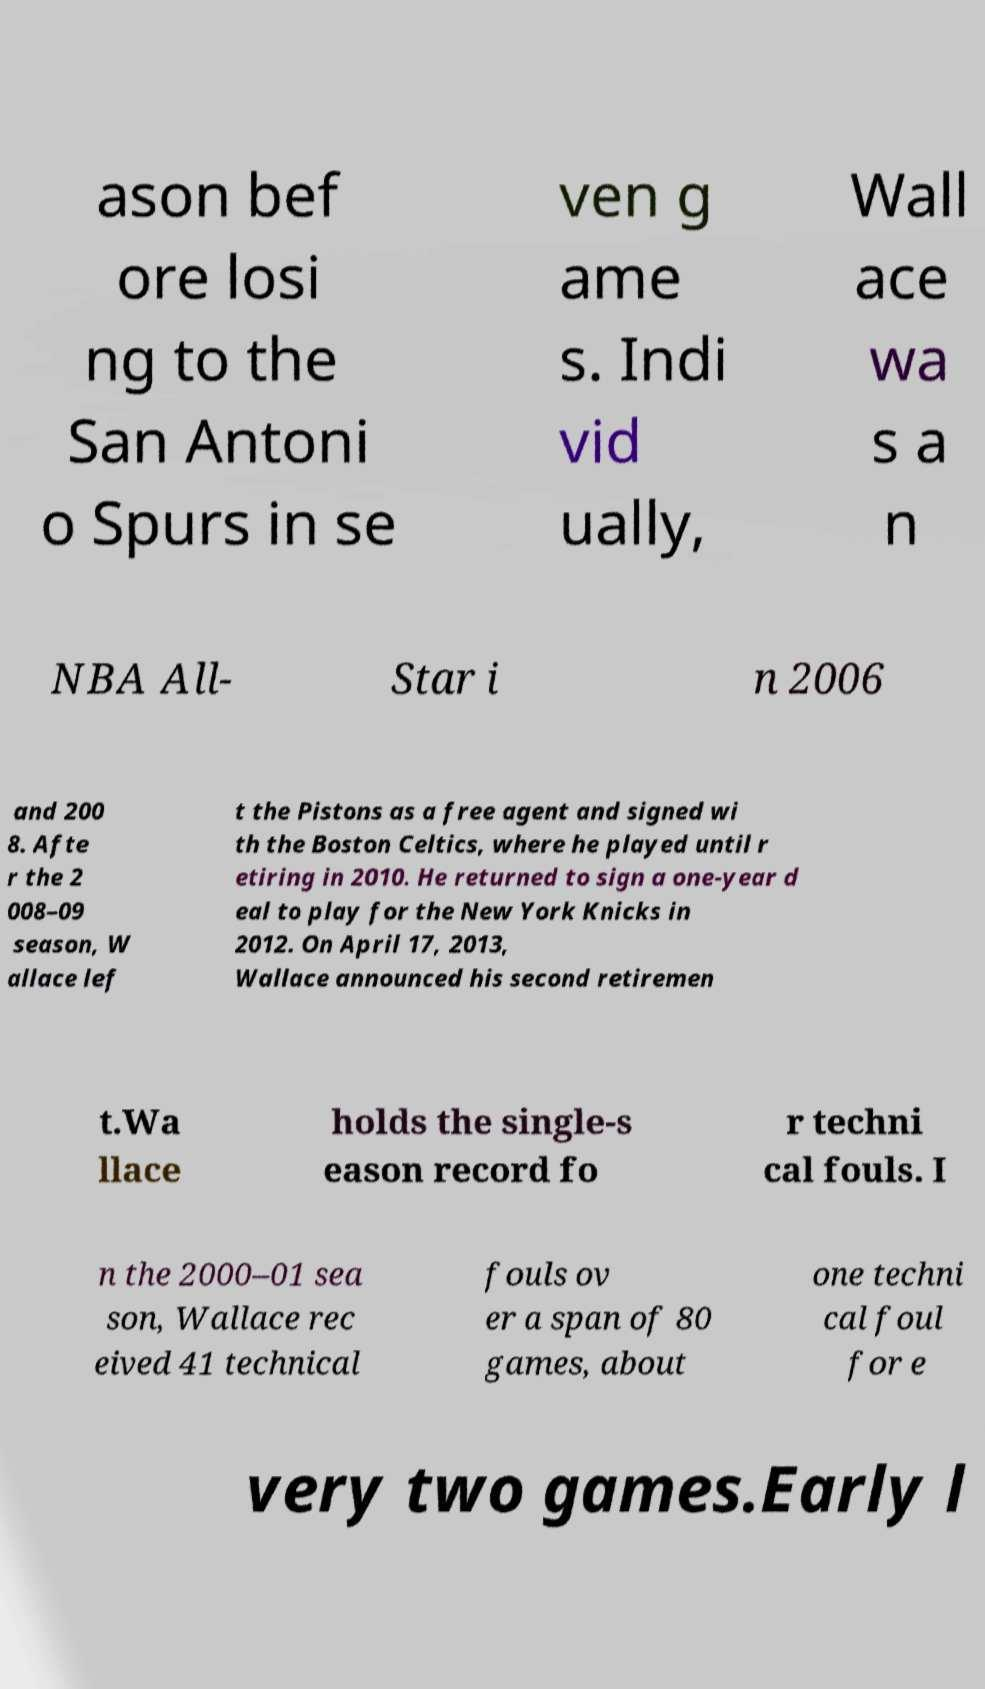Can you read and provide the text displayed in the image?This photo seems to have some interesting text. Can you extract and type it out for me? ason bef ore losi ng to the San Antoni o Spurs in se ven g ame s. Indi vid ually, Wall ace wa s a n NBA All- Star i n 2006 and 200 8. Afte r the 2 008–09 season, W allace lef t the Pistons as a free agent and signed wi th the Boston Celtics, where he played until r etiring in 2010. He returned to sign a one-year d eal to play for the New York Knicks in 2012. On April 17, 2013, Wallace announced his second retiremen t.Wa llace holds the single-s eason record fo r techni cal fouls. I n the 2000–01 sea son, Wallace rec eived 41 technical fouls ov er a span of 80 games, about one techni cal foul for e very two games.Early l 